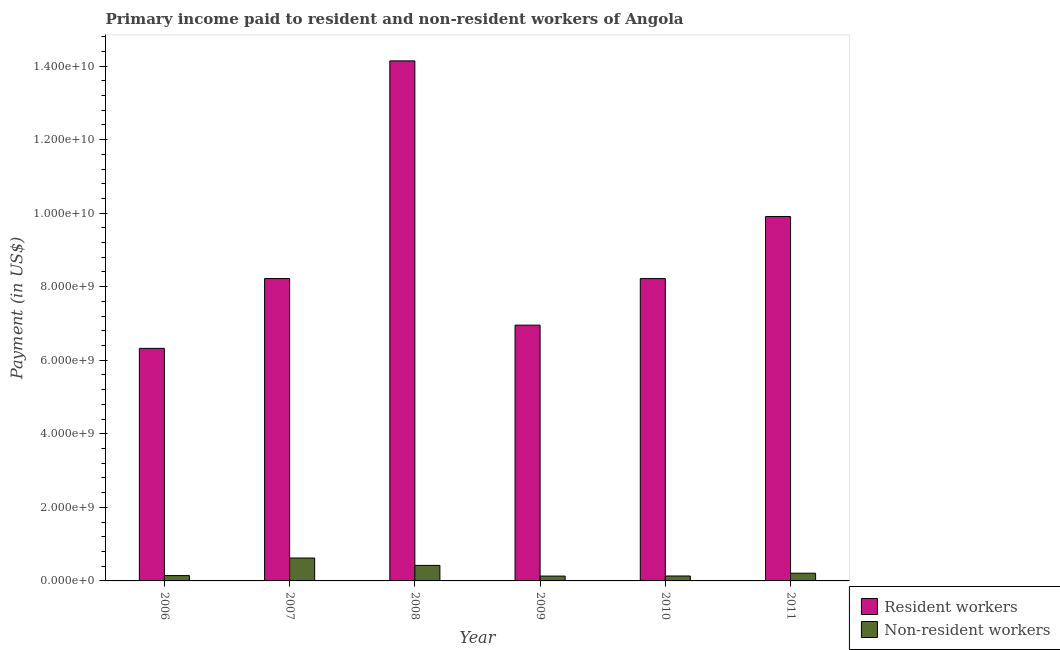How many groups of bars are there?
Give a very brief answer. 6. Are the number of bars per tick equal to the number of legend labels?
Offer a terse response. Yes. Are the number of bars on each tick of the X-axis equal?
Give a very brief answer. Yes. In how many cases, is the number of bars for a given year not equal to the number of legend labels?
Keep it short and to the point. 0. What is the payment made to non-resident workers in 2006?
Your answer should be very brief. 1.45e+08. Across all years, what is the maximum payment made to non-resident workers?
Your answer should be compact. 6.23e+08. Across all years, what is the minimum payment made to resident workers?
Your answer should be very brief. 6.32e+09. What is the total payment made to non-resident workers in the graph?
Offer a terse response. 1.67e+09. What is the difference between the payment made to resident workers in 2010 and that in 2011?
Offer a terse response. -1.69e+09. What is the difference between the payment made to resident workers in 2006 and the payment made to non-resident workers in 2009?
Offer a terse response. -6.32e+08. What is the average payment made to non-resident workers per year?
Give a very brief answer. 2.78e+08. In the year 2007, what is the difference between the payment made to resident workers and payment made to non-resident workers?
Offer a terse response. 0. In how many years, is the payment made to resident workers greater than 5600000000 US$?
Offer a very short reply. 6. What is the ratio of the payment made to non-resident workers in 2009 to that in 2011?
Provide a succinct answer. 0.63. Is the payment made to non-resident workers in 2010 less than that in 2011?
Your response must be concise. Yes. What is the difference between the highest and the second highest payment made to resident workers?
Your answer should be compact. 4.23e+09. What is the difference between the highest and the lowest payment made to resident workers?
Make the answer very short. 7.82e+09. Is the sum of the payment made to resident workers in 2006 and 2008 greater than the maximum payment made to non-resident workers across all years?
Provide a short and direct response. Yes. What does the 1st bar from the left in 2007 represents?
Your answer should be very brief. Resident workers. What does the 1st bar from the right in 2010 represents?
Keep it short and to the point. Non-resident workers. Are the values on the major ticks of Y-axis written in scientific E-notation?
Your answer should be compact. Yes. Where does the legend appear in the graph?
Ensure brevity in your answer.  Bottom right. How many legend labels are there?
Your answer should be compact. 2. What is the title of the graph?
Offer a terse response. Primary income paid to resident and non-resident workers of Angola. What is the label or title of the X-axis?
Offer a terse response. Year. What is the label or title of the Y-axis?
Offer a very short reply. Payment (in US$). What is the Payment (in US$) in Resident workers in 2006?
Provide a succinct answer. 6.32e+09. What is the Payment (in US$) in Non-resident workers in 2006?
Provide a short and direct response. 1.45e+08. What is the Payment (in US$) of Resident workers in 2007?
Offer a terse response. 8.22e+09. What is the Payment (in US$) of Non-resident workers in 2007?
Your response must be concise. 6.23e+08. What is the Payment (in US$) in Resident workers in 2008?
Ensure brevity in your answer.  1.41e+1. What is the Payment (in US$) of Non-resident workers in 2008?
Give a very brief answer. 4.22e+08. What is the Payment (in US$) in Resident workers in 2009?
Keep it short and to the point. 6.95e+09. What is the Payment (in US$) in Non-resident workers in 2009?
Offer a terse response. 1.31e+08. What is the Payment (in US$) of Resident workers in 2010?
Your answer should be compact. 8.22e+09. What is the Payment (in US$) of Non-resident workers in 2010?
Your answer should be compact. 1.34e+08. What is the Payment (in US$) of Resident workers in 2011?
Your answer should be compact. 9.91e+09. What is the Payment (in US$) of Non-resident workers in 2011?
Keep it short and to the point. 2.10e+08. Across all years, what is the maximum Payment (in US$) in Resident workers?
Give a very brief answer. 1.41e+1. Across all years, what is the maximum Payment (in US$) of Non-resident workers?
Provide a succinct answer. 6.23e+08. Across all years, what is the minimum Payment (in US$) in Resident workers?
Keep it short and to the point. 6.32e+09. Across all years, what is the minimum Payment (in US$) of Non-resident workers?
Your response must be concise. 1.31e+08. What is the total Payment (in US$) in Resident workers in the graph?
Your response must be concise. 5.38e+1. What is the total Payment (in US$) in Non-resident workers in the graph?
Your answer should be very brief. 1.67e+09. What is the difference between the Payment (in US$) in Resident workers in 2006 and that in 2007?
Your answer should be compact. -1.90e+09. What is the difference between the Payment (in US$) of Non-resident workers in 2006 and that in 2007?
Ensure brevity in your answer.  -4.78e+08. What is the difference between the Payment (in US$) in Resident workers in 2006 and that in 2008?
Your response must be concise. -7.82e+09. What is the difference between the Payment (in US$) of Non-resident workers in 2006 and that in 2008?
Your answer should be compact. -2.77e+08. What is the difference between the Payment (in US$) in Resident workers in 2006 and that in 2009?
Provide a succinct answer. -6.32e+08. What is the difference between the Payment (in US$) in Non-resident workers in 2006 and that in 2009?
Make the answer very short. 1.37e+07. What is the difference between the Payment (in US$) of Resident workers in 2006 and that in 2010?
Keep it short and to the point. -1.90e+09. What is the difference between the Payment (in US$) in Non-resident workers in 2006 and that in 2010?
Make the answer very short. 1.10e+07. What is the difference between the Payment (in US$) in Resident workers in 2006 and that in 2011?
Your answer should be compact. -3.58e+09. What is the difference between the Payment (in US$) of Non-resident workers in 2006 and that in 2011?
Your answer should be compact. -6.48e+07. What is the difference between the Payment (in US$) of Resident workers in 2007 and that in 2008?
Offer a very short reply. -5.92e+09. What is the difference between the Payment (in US$) in Non-resident workers in 2007 and that in 2008?
Make the answer very short. 2.00e+08. What is the difference between the Payment (in US$) in Resident workers in 2007 and that in 2009?
Offer a very short reply. 1.27e+09. What is the difference between the Payment (in US$) of Non-resident workers in 2007 and that in 2009?
Make the answer very short. 4.91e+08. What is the difference between the Payment (in US$) of Resident workers in 2007 and that in 2010?
Offer a very short reply. 6.88e+05. What is the difference between the Payment (in US$) in Non-resident workers in 2007 and that in 2010?
Give a very brief answer. 4.89e+08. What is the difference between the Payment (in US$) in Resident workers in 2007 and that in 2011?
Make the answer very short. -1.69e+09. What is the difference between the Payment (in US$) in Non-resident workers in 2007 and that in 2011?
Your answer should be very brief. 4.13e+08. What is the difference between the Payment (in US$) in Resident workers in 2008 and that in 2009?
Your answer should be very brief. 7.19e+09. What is the difference between the Payment (in US$) in Non-resident workers in 2008 and that in 2009?
Give a very brief answer. 2.91e+08. What is the difference between the Payment (in US$) in Resident workers in 2008 and that in 2010?
Provide a succinct answer. 5.92e+09. What is the difference between the Payment (in US$) in Non-resident workers in 2008 and that in 2010?
Your answer should be compact. 2.88e+08. What is the difference between the Payment (in US$) of Resident workers in 2008 and that in 2011?
Make the answer very short. 4.23e+09. What is the difference between the Payment (in US$) of Non-resident workers in 2008 and that in 2011?
Offer a very short reply. 2.12e+08. What is the difference between the Payment (in US$) of Resident workers in 2009 and that in 2010?
Your answer should be compact. -1.27e+09. What is the difference between the Payment (in US$) of Non-resident workers in 2009 and that in 2010?
Offer a very short reply. -2.70e+06. What is the difference between the Payment (in US$) in Resident workers in 2009 and that in 2011?
Make the answer very short. -2.95e+09. What is the difference between the Payment (in US$) of Non-resident workers in 2009 and that in 2011?
Make the answer very short. -7.85e+07. What is the difference between the Payment (in US$) of Resident workers in 2010 and that in 2011?
Your response must be concise. -1.69e+09. What is the difference between the Payment (in US$) of Non-resident workers in 2010 and that in 2011?
Your answer should be compact. -7.58e+07. What is the difference between the Payment (in US$) in Resident workers in 2006 and the Payment (in US$) in Non-resident workers in 2007?
Provide a succinct answer. 5.70e+09. What is the difference between the Payment (in US$) of Resident workers in 2006 and the Payment (in US$) of Non-resident workers in 2008?
Make the answer very short. 5.90e+09. What is the difference between the Payment (in US$) in Resident workers in 2006 and the Payment (in US$) in Non-resident workers in 2009?
Offer a very short reply. 6.19e+09. What is the difference between the Payment (in US$) of Resident workers in 2006 and the Payment (in US$) of Non-resident workers in 2010?
Your answer should be very brief. 6.19e+09. What is the difference between the Payment (in US$) in Resident workers in 2006 and the Payment (in US$) in Non-resident workers in 2011?
Give a very brief answer. 6.11e+09. What is the difference between the Payment (in US$) of Resident workers in 2007 and the Payment (in US$) of Non-resident workers in 2008?
Offer a very short reply. 7.80e+09. What is the difference between the Payment (in US$) of Resident workers in 2007 and the Payment (in US$) of Non-resident workers in 2009?
Your answer should be very brief. 8.09e+09. What is the difference between the Payment (in US$) of Resident workers in 2007 and the Payment (in US$) of Non-resident workers in 2010?
Keep it short and to the point. 8.09e+09. What is the difference between the Payment (in US$) in Resident workers in 2007 and the Payment (in US$) in Non-resident workers in 2011?
Provide a short and direct response. 8.01e+09. What is the difference between the Payment (in US$) of Resident workers in 2008 and the Payment (in US$) of Non-resident workers in 2009?
Your answer should be compact. 1.40e+1. What is the difference between the Payment (in US$) in Resident workers in 2008 and the Payment (in US$) in Non-resident workers in 2010?
Provide a short and direct response. 1.40e+1. What is the difference between the Payment (in US$) of Resident workers in 2008 and the Payment (in US$) of Non-resident workers in 2011?
Your answer should be very brief. 1.39e+1. What is the difference between the Payment (in US$) in Resident workers in 2009 and the Payment (in US$) in Non-resident workers in 2010?
Make the answer very short. 6.82e+09. What is the difference between the Payment (in US$) in Resident workers in 2009 and the Payment (in US$) in Non-resident workers in 2011?
Provide a succinct answer. 6.74e+09. What is the difference between the Payment (in US$) of Resident workers in 2010 and the Payment (in US$) of Non-resident workers in 2011?
Offer a terse response. 8.01e+09. What is the average Payment (in US$) in Resident workers per year?
Provide a short and direct response. 8.96e+09. What is the average Payment (in US$) of Non-resident workers per year?
Provide a short and direct response. 2.78e+08. In the year 2006, what is the difference between the Payment (in US$) of Resident workers and Payment (in US$) of Non-resident workers?
Your answer should be compact. 6.18e+09. In the year 2007, what is the difference between the Payment (in US$) of Resident workers and Payment (in US$) of Non-resident workers?
Keep it short and to the point. 7.60e+09. In the year 2008, what is the difference between the Payment (in US$) of Resident workers and Payment (in US$) of Non-resident workers?
Your answer should be very brief. 1.37e+1. In the year 2009, what is the difference between the Payment (in US$) of Resident workers and Payment (in US$) of Non-resident workers?
Offer a very short reply. 6.82e+09. In the year 2010, what is the difference between the Payment (in US$) of Resident workers and Payment (in US$) of Non-resident workers?
Give a very brief answer. 8.09e+09. In the year 2011, what is the difference between the Payment (in US$) of Resident workers and Payment (in US$) of Non-resident workers?
Your answer should be compact. 9.70e+09. What is the ratio of the Payment (in US$) in Resident workers in 2006 to that in 2007?
Ensure brevity in your answer.  0.77. What is the ratio of the Payment (in US$) in Non-resident workers in 2006 to that in 2007?
Give a very brief answer. 0.23. What is the ratio of the Payment (in US$) of Resident workers in 2006 to that in 2008?
Offer a very short reply. 0.45. What is the ratio of the Payment (in US$) of Non-resident workers in 2006 to that in 2008?
Your answer should be very brief. 0.34. What is the ratio of the Payment (in US$) in Resident workers in 2006 to that in 2009?
Make the answer very short. 0.91. What is the ratio of the Payment (in US$) of Non-resident workers in 2006 to that in 2009?
Your answer should be very brief. 1.1. What is the ratio of the Payment (in US$) of Resident workers in 2006 to that in 2010?
Make the answer very short. 0.77. What is the ratio of the Payment (in US$) of Non-resident workers in 2006 to that in 2010?
Keep it short and to the point. 1.08. What is the ratio of the Payment (in US$) in Resident workers in 2006 to that in 2011?
Give a very brief answer. 0.64. What is the ratio of the Payment (in US$) in Non-resident workers in 2006 to that in 2011?
Offer a terse response. 0.69. What is the ratio of the Payment (in US$) of Resident workers in 2007 to that in 2008?
Your response must be concise. 0.58. What is the ratio of the Payment (in US$) in Non-resident workers in 2007 to that in 2008?
Keep it short and to the point. 1.47. What is the ratio of the Payment (in US$) in Resident workers in 2007 to that in 2009?
Your response must be concise. 1.18. What is the ratio of the Payment (in US$) in Non-resident workers in 2007 to that in 2009?
Give a very brief answer. 4.74. What is the ratio of the Payment (in US$) of Non-resident workers in 2007 to that in 2010?
Offer a terse response. 4.64. What is the ratio of the Payment (in US$) of Resident workers in 2007 to that in 2011?
Provide a succinct answer. 0.83. What is the ratio of the Payment (in US$) in Non-resident workers in 2007 to that in 2011?
Offer a very short reply. 2.97. What is the ratio of the Payment (in US$) in Resident workers in 2008 to that in 2009?
Give a very brief answer. 2.03. What is the ratio of the Payment (in US$) in Non-resident workers in 2008 to that in 2009?
Keep it short and to the point. 3.22. What is the ratio of the Payment (in US$) of Resident workers in 2008 to that in 2010?
Offer a terse response. 1.72. What is the ratio of the Payment (in US$) in Non-resident workers in 2008 to that in 2010?
Provide a short and direct response. 3.15. What is the ratio of the Payment (in US$) of Resident workers in 2008 to that in 2011?
Give a very brief answer. 1.43. What is the ratio of the Payment (in US$) of Non-resident workers in 2008 to that in 2011?
Keep it short and to the point. 2.01. What is the ratio of the Payment (in US$) in Resident workers in 2009 to that in 2010?
Your answer should be very brief. 0.85. What is the ratio of the Payment (in US$) of Non-resident workers in 2009 to that in 2010?
Provide a short and direct response. 0.98. What is the ratio of the Payment (in US$) in Resident workers in 2009 to that in 2011?
Offer a very short reply. 0.7. What is the ratio of the Payment (in US$) of Non-resident workers in 2009 to that in 2011?
Offer a terse response. 0.63. What is the ratio of the Payment (in US$) of Resident workers in 2010 to that in 2011?
Provide a short and direct response. 0.83. What is the ratio of the Payment (in US$) in Non-resident workers in 2010 to that in 2011?
Provide a short and direct response. 0.64. What is the difference between the highest and the second highest Payment (in US$) in Resident workers?
Give a very brief answer. 4.23e+09. What is the difference between the highest and the second highest Payment (in US$) of Non-resident workers?
Make the answer very short. 2.00e+08. What is the difference between the highest and the lowest Payment (in US$) in Resident workers?
Keep it short and to the point. 7.82e+09. What is the difference between the highest and the lowest Payment (in US$) in Non-resident workers?
Make the answer very short. 4.91e+08. 